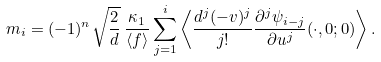Convert formula to latex. <formula><loc_0><loc_0><loc_500><loc_500>m _ { i } = ( - 1 ) ^ { n } \sqrt { \frac { 2 } { d } } \, \frac { \kappa _ { 1 } } { \langle f \rangle } \sum _ { j = 1 } ^ { i } \left \langle \frac { d ^ { j } ( - v ) ^ { j } } { j ! } \frac { \partial ^ { j } \psi _ { i - j } } { \partial u ^ { j } } ( \cdot , 0 ; 0 ) \right \rangle .</formula> 